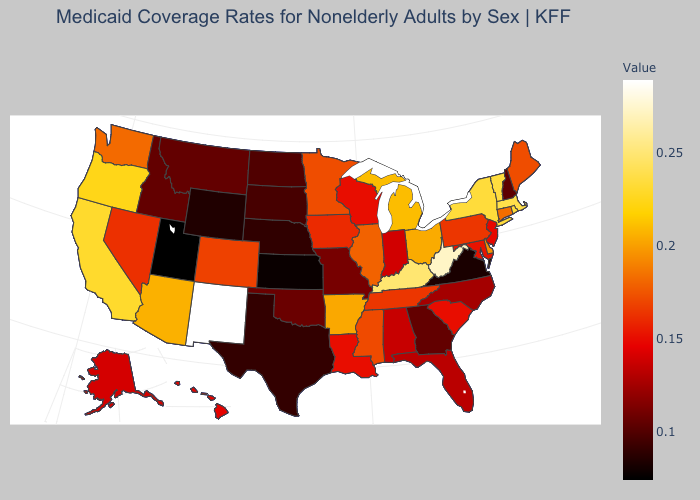Among the states that border Rhode Island , which have the highest value?
Quick response, please. Massachusetts. Does New York have a lower value than Wyoming?
Answer briefly. No. Does Utah have the lowest value in the USA?
Quick response, please. Yes. Does Indiana have the lowest value in the USA?
Give a very brief answer. No. Which states have the lowest value in the USA?
Answer briefly. Utah. 